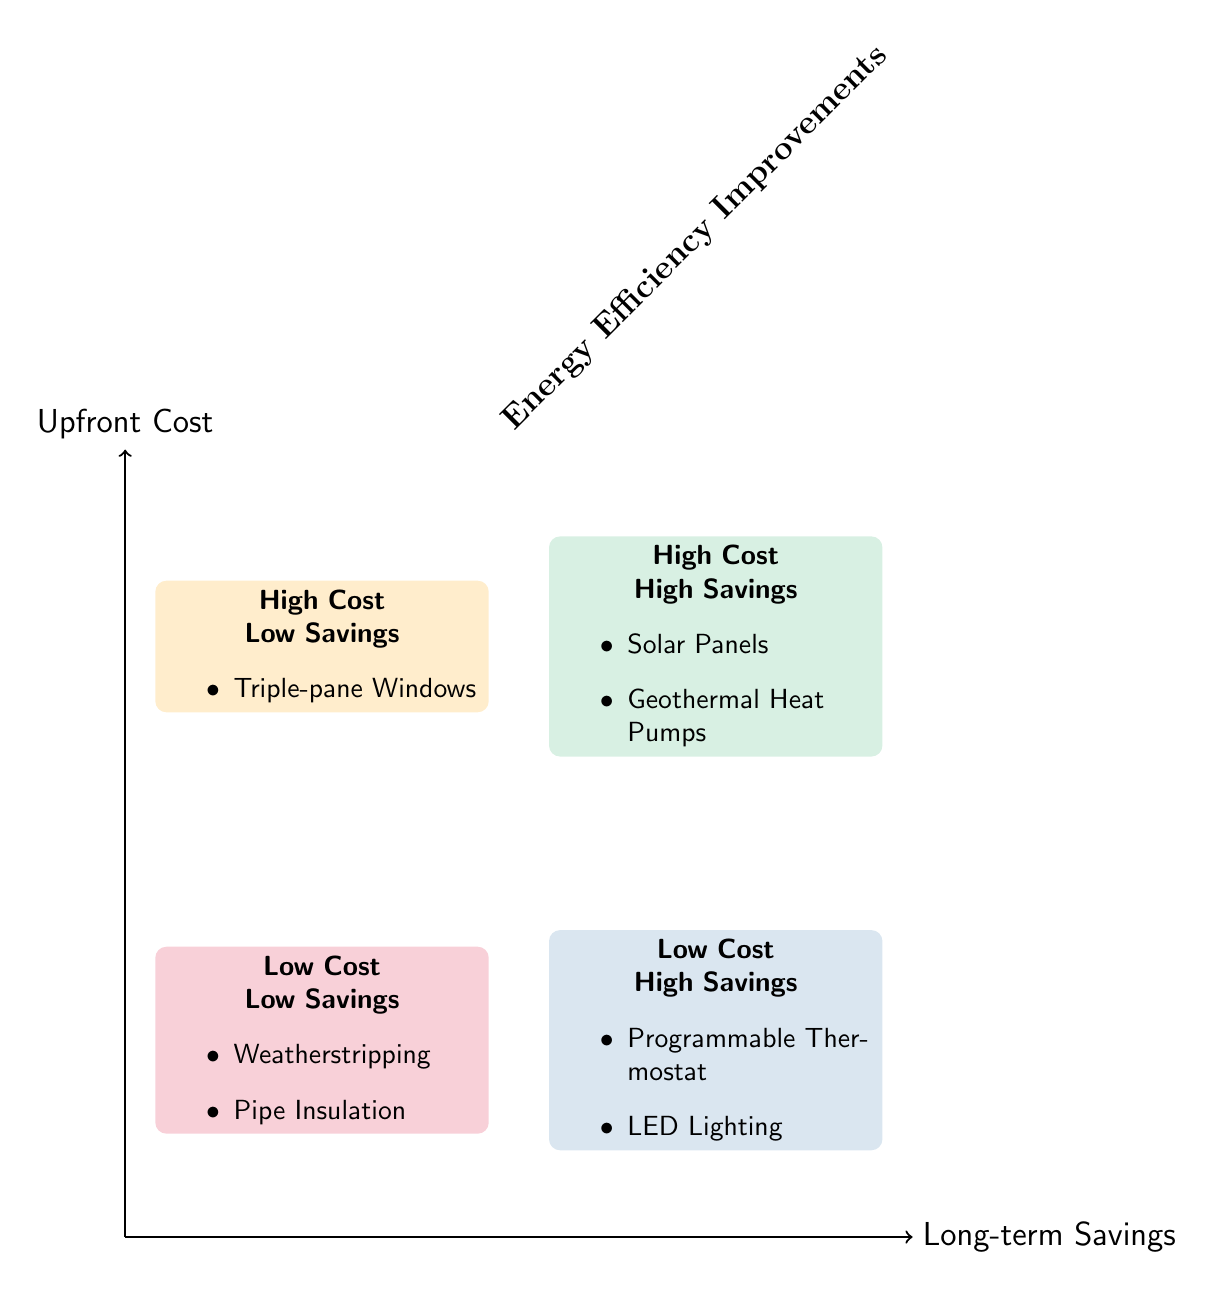What energy efficiency improvement has high upfront cost and high long-term savings? The diagram shows that "Solar Panels" and "Geothermal Heat Pumps" are categorized in the section marked as high upfront cost and high long-term savings.
Answer: Solar Panels, Geothermal Heat Pumps How many improvements are listed in the low cost, low savings quadrant? By examining the low cost, low savings quadrant, we find that there are two improvements: "Weatherstripping" and "Pipe Insulation."
Answer: 2 Which energy efficiency improvement offers significant savings on heating and cooling? The "Geothermal Heat Pumps" under the high upfront cost, high long-term savings section indicates they provide significant savings on heating and cooling.
Answer: Geothermal Heat Pumps What is the only improvement categorized as high upfront cost and low long-term savings? In the high upfront cost and low long-term savings quadrant, the only listed improvement is "Triple-pane Windows."
Answer: Triple-pane Windows Identify two improvements with low upfront costs that provide high long-term savings. In the low upfront cost, high long-term savings quadrant, "Programmable Thermostat" and "LED Lighting" are depicted as the improvements that fit this category.
Answer: Programmable Thermostat, LED Lighting Which quadrant contains minor investments with small improvements in energy efficiency? The quadrant in the bottom left labeled low cost, low savings contains improvements that represent minor investments with small efficiency gains: "Weatherstripping" and "Pipe Insulation."
Answer: Low Cost - Low Savings Which improvement is categorized under high cost but provides low long-term savings? "Triple-pane Windows" is the single improvement listed in the high upfront cost, low long-term savings quadrant, indicating it is costly but yields minimal savings.
Answer: Triple-pane Windows Which type of lighting is represented as having low upfront cost and high long-term savings? "LED Lighting," found in the low upfront cost, high long-term savings quadrant, is identified as a cost-effective option for energy efficiency.
Answer: LED Lighting 